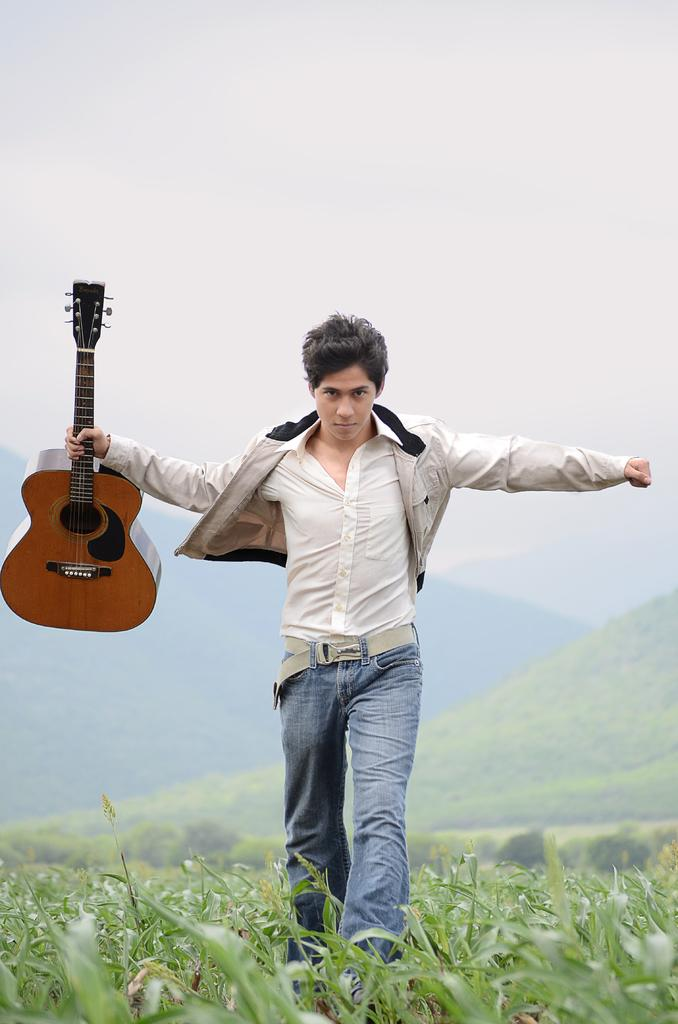What is the main subject of the image? The main subject of the image is a boy. Can you describe what the boy is wearing? The boy is wearing a white jacket, white shirt, and jeans pants. What is the boy holding in his hand? The boy is holding a guitar in his hand. What is the boy doing in the image? The boy is walking on the grass. What can be seen in the background of the image? There are hills visible in the background of the image. What word is written on the scarecrow in the image? There is no scarecrow present in the image, so it is not possible to answer that question. --- Facts: 1. There is a car in the image. 2. The car is red. 3. The car has four wheels. 4. The car has a license plate. 5. The car is parked on the street. Absurd Topics: bird, ocean, mountain Conversation: What is the main subject of the image? The main subject of the image is a car. Can you describe the color of the car? The car is red. How many wheels does the car have? The car has four wheels. Does the car have any identifying features? Yes, the car has a license plate. Where is the car located in the image? The car is parked on the street. Reasoning: Let's think step by step in order to produce the conversation. We start by identifying the main subject of the image, which is the car. Then, we describe specific features of the car, such as its color, number of wheels, and the presence of a license plate. Finally, we mention the car's location, which is parked on the street. Absurd Question/Answer: Can you see any birds flying over the car in the image? There are no birds visible in the image. 